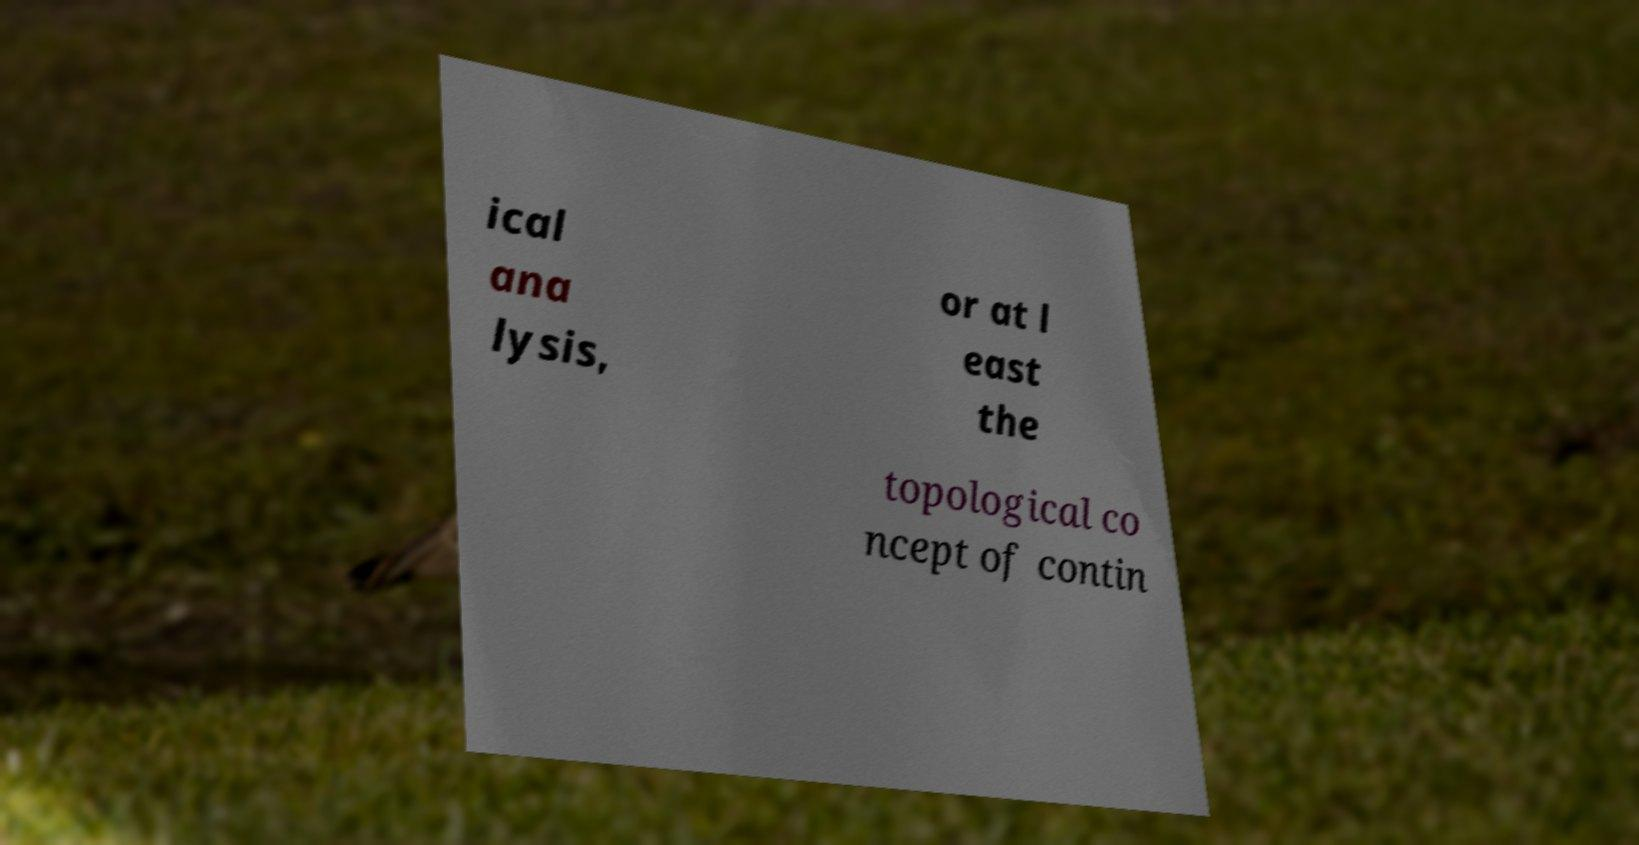Please read and relay the text visible in this image. What does it say? ical ana lysis, or at l east the topological co ncept of contin 